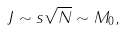Convert formula to latex. <formula><loc_0><loc_0><loc_500><loc_500>J \sim s \sqrt { N } \sim M _ { 0 } ,</formula> 